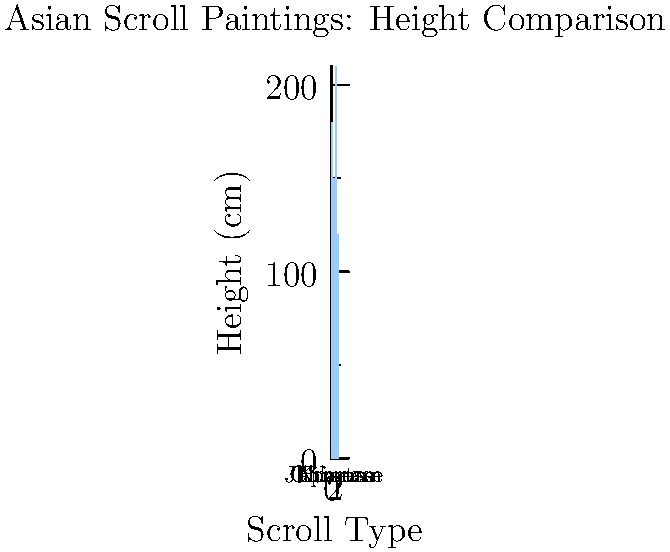As a connoisseur of Asian art, you're considering adding a new scroll painting to your collection. Based on the graph showing the average heights of scroll paintings from different Asian traditions, which type of scroll painting would require the most vertical wall space in your gallery? To determine which type of scroll painting requires the most vertical wall space, we need to compare the heights of the different scroll types shown in the graph. Let's analyze the data step-by-step:

1. Chinese scroll: approximately 180 cm tall
2. Japanese scroll: approximately 150 cm tall
3. Korean scroll: approximately 210 cm tall
4. Tibetan scroll: approximately 120 cm tall

Comparing these heights:
- The Korean scroll is taller than the Chinese scroll
- The Chinese scroll is taller than the Japanese scroll
- The Japanese scroll is taller than the Tibetan scroll

Therefore, the Korean scroll, with a height of about 210 cm, is the tallest among the four types shown.

As a wealthy patron looking to maximize the impact of your collection, you would need to allocate the most vertical wall space for a Korean scroll painting.
Answer: Korean scroll 